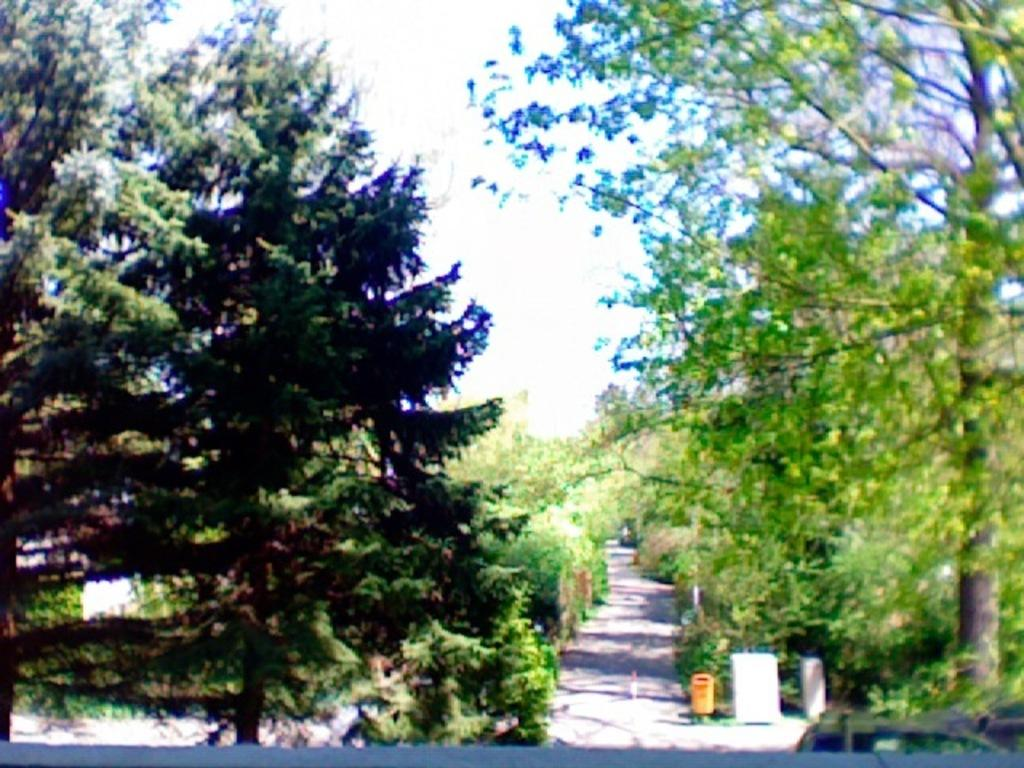What is the main feature of the image? There is a road in the image. What can be found on the side of the road? There is a yellow color bin on the side of the road. What type of vegetation is present alongside the road? There are trees on the sides of the road. What is visible in the background of the image? There is sky visible in the background of the image. What type of bead is hanging from the trees in the image? There are no beads present in the image; it features a road, a yellow color bin, trees, and sky. What color is the tongue of the person walking on the road in the image? There are no people or tongues visible in the image. 